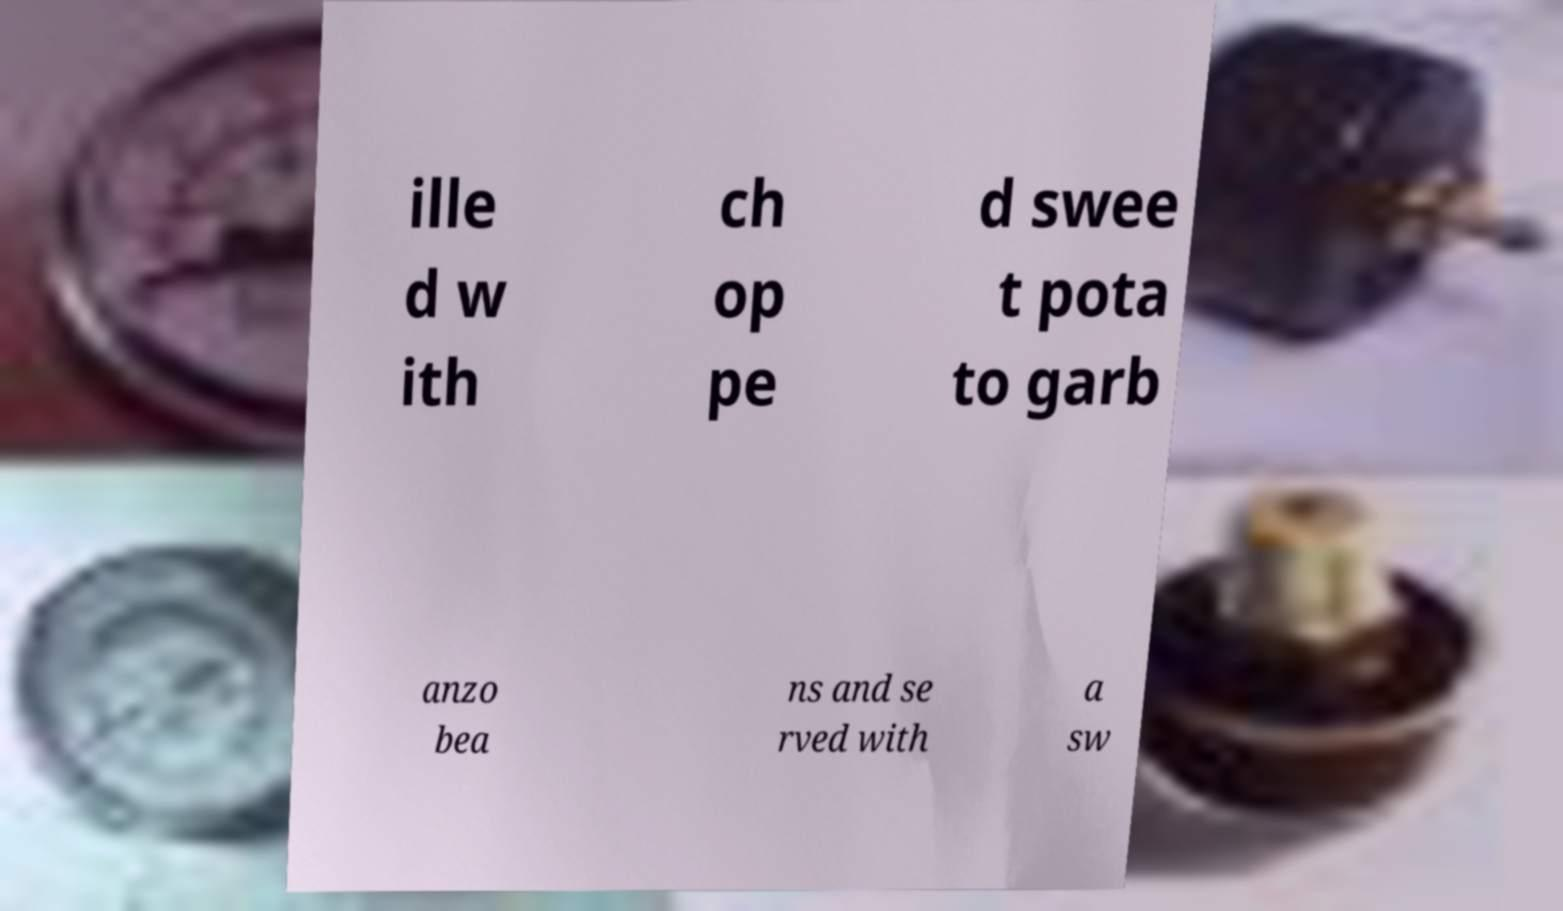Can you read and provide the text displayed in the image?This photo seems to have some interesting text. Can you extract and type it out for me? ille d w ith ch op pe d swee t pota to garb anzo bea ns and se rved with a sw 